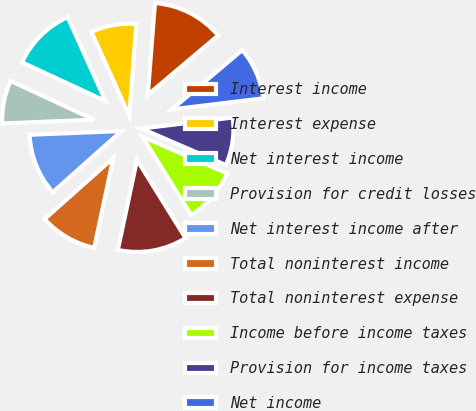Convert chart. <chart><loc_0><loc_0><loc_500><loc_500><pie_chart><fcel>Interest income<fcel>Interest expense<fcel>Net interest income<fcel>Provision for credit losses<fcel>Net interest income after<fcel>Total noninterest income<fcel>Total noninterest expense<fcel>Income before income taxes<fcel>Provision for income taxes<fcel>Net income<nl><fcel>12.61%<fcel>7.98%<fcel>11.34%<fcel>7.56%<fcel>10.92%<fcel>10.08%<fcel>12.18%<fcel>9.66%<fcel>8.4%<fcel>9.24%<nl></chart> 